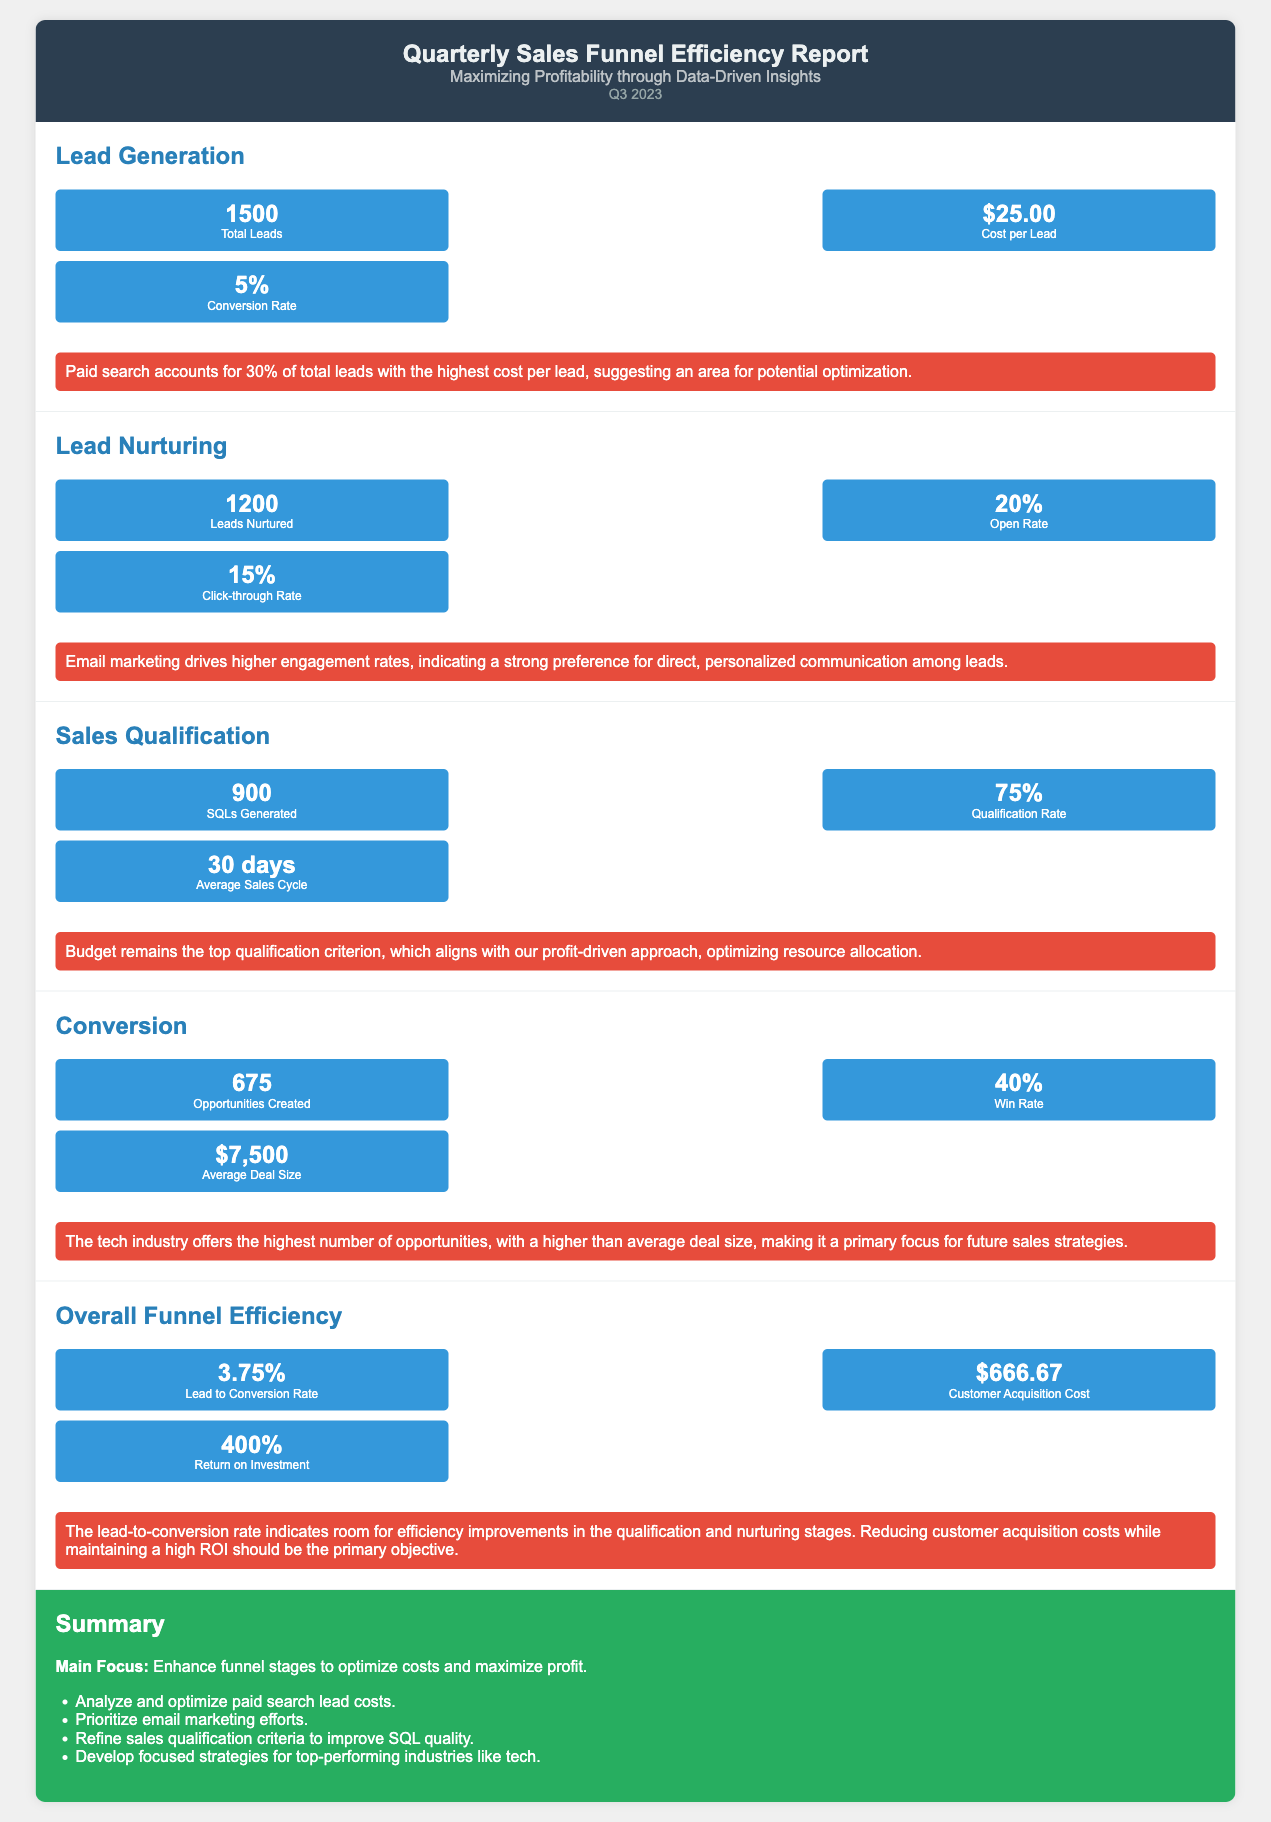What is the total number of leads? The total leads are reported in the Lead Generation section as 1500.
Answer: 1500 What is the cost per lead? The cost per lead is specified in the Lead Generation section as $25.00.
Answer: $25.00 What is the conversion rate for Sales Qualification? The conversion rate in the Sales Qualification section is indicated as 75%.
Answer: 75% How many opportunities were created? The number of opportunities created is mentioned in the Conversion section as 675.
Answer: 675 What is the lead to conversion rate? The lead to conversion rate is stated in the Overall Funnel Efficiency section as 3.75%.
Answer: 3.75% What is the average deal size? The average deal size is mentioned in the Conversion section as $7,500.
Answer: $7,500 Which marketing channel accounts for 30% of total leads? The document mentions that paid search accounts for this percentage in the Lead Generation section.
Answer: Paid search What is the average sales cycle duration? The average sales cycle duration is listed in the Sales Qualification section as 30 days.
Answer: 30 days What is the overall focus of the report? The summary highlights the main focus as enhancing funnel stages to optimize costs and maximize profit.
Answer: Enhance funnel stages to optimize costs and maximize profit 